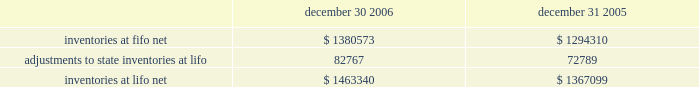Advance auto parts , inc .
And subsidiaries notes to consolidated financial statements 2013 ( continued ) december 30 , 2006 , december 31 , 2005 and january 1 , 2005 ( in thousands , except per share data ) 8 .
Inventories , net inventories are stated at the lower of cost or market , cost being determined using the last-in , first-out ( "lifo" ) method for approximately 93% ( 93 % ) of inventories at both december 30 , 2006 and december 31 , 2005 .
Under the lifo method , the company 2019s cost of sales reflects the costs of the most currently purchased inventories while the inventory carrying balance represents the costs relating to prices paid in prior years .
The company 2019s costs to acquire inventory have been generally decreasing in recent years as a result of its significant growth .
Accordingly , the cost to replace inventory is less than the lifo balances carried for similar product .
As a result of the lifo method and the ability to obtain lower product costs , the company recorded a reduction to cost of sales of $ 9978 for fiscal year ended 2006 , an increase in cost of sales of $ 526 for fiscal year ended 2005 and a reduction to cost of sales of $ 11212 for fiscal year ended 2004 .
The remaining inventories are comprised of product cores , which consist of the non-consumable portion of certain parts and batteries and are valued under the first-in , first-out ( "fifo" ) method .
Core values are included as part of our merchandise costs and are either passed on to the customer or returned to the vendor .
Additionally , these products are not subject to the frequent cost changes like our other merchandise inventory , thus , there is no material difference from applying either the lifo or fifo valuation methods .
The company capitalizes certain purchasing and warehousing costs into inventory .
Purchasing and warehousing costs included in inventory , at fifo , at december 30 , 2006 and december 31 , 2005 , were $ 95576 and $ 92833 , respectively .
Inventories consist of the following : december 30 , december 31 , 2006 2005 .
Replacement cost approximated fifo cost at december 30 , 2006 and december 31 , 2005 .
Inventory quantities are tracked through a perpetual inventory system .
The company uses a cycle counting program in all distribution centers , parts delivered quickly warehouses , or pdqs , local area warehouses , or laws , and retail stores to ensure the accuracy of the perpetual inventory quantities of both merchandise and core inventory .
The company establishes reserves for estimated shrink based on historical accuracy and effectiveness of the cycle counting program .
The company also establishes reserves for potentially excess and obsolete inventories based on current inventory levels and the historical analysis of product sales and current market conditions .
The nature of the company 2019s inventory is such that the risk of obsolescence is minimal and excess inventory has historically been returned to the company 2019s vendors for credit .
The company provides reserves when less than full credit is expected from a vendor or when liquidating product will result in retail prices below recorded costs .
The company 2019s reserves against inventory for these matters were $ 31376 and $ 22825 at december 30 , 2006 and december 31 , 2005 , respectively .
Property and equipment : property and equipment are stated at cost , less accumulated depreciation .
Expenditures for maintenance and repairs are charged directly to expense when incurred ; major improvements are capitalized .
When items are sold or retired , the related cost and accumulated depreciation are removed from the accounts , with any gain or loss reflected in the consolidated statements of operations .
Depreciation of land improvements , buildings , furniture , fixtures and equipment , and vehicles is provided over the estimated useful lives , which range from 2 to 40 years , of the respective assets using the straight-line method. .
What is the percentage increase in inventories due to the adoption of lifo in 2006? 
Computations: (82767 / 1380573)
Answer: 0.05995. 